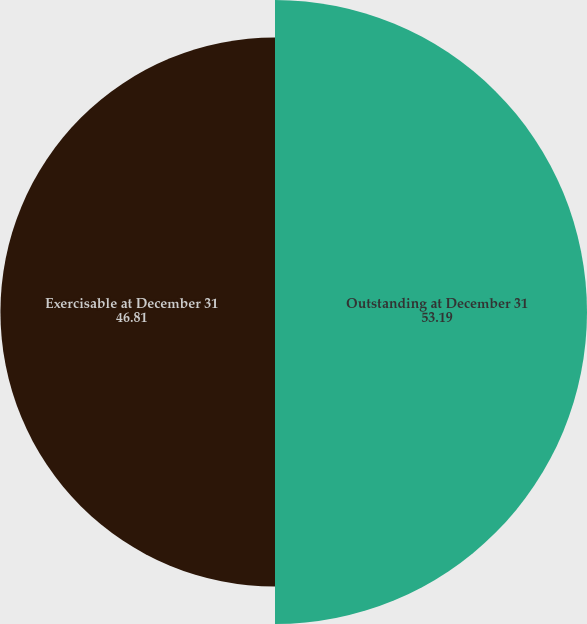<chart> <loc_0><loc_0><loc_500><loc_500><pie_chart><fcel>Outstanding at December 31<fcel>Exercisable at December 31<nl><fcel>53.19%<fcel>46.81%<nl></chart> 